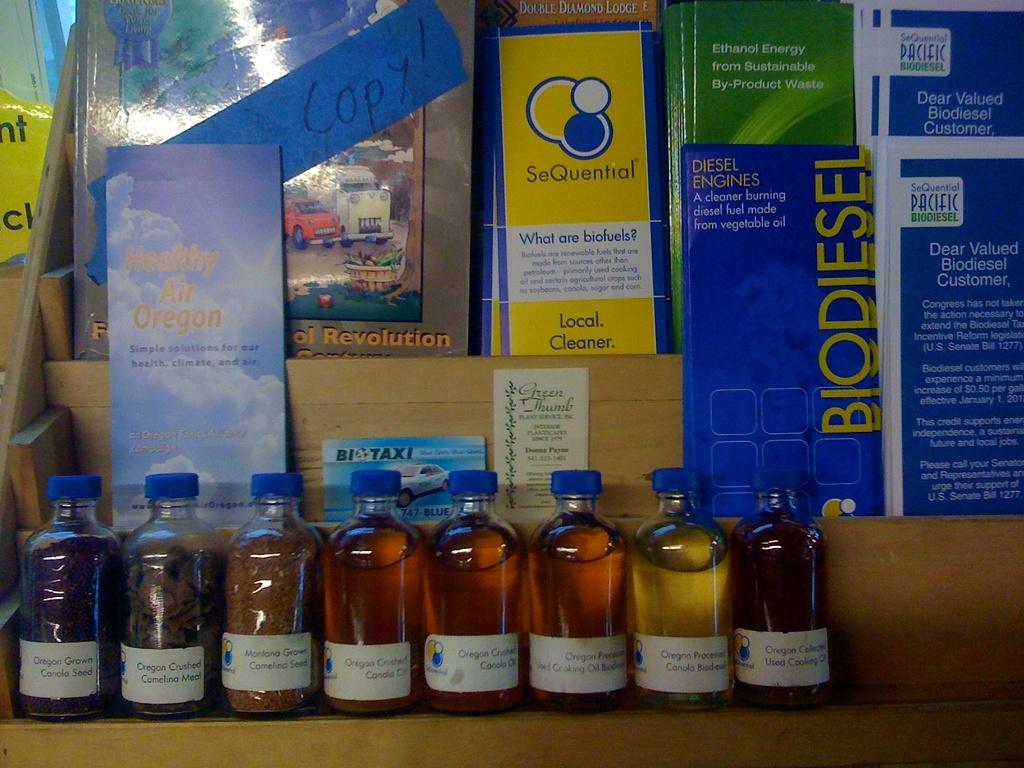<image>
Provide a brief description of the given image. bottles like Oregon Crushed Camelina Meal in front of various pamphlets 